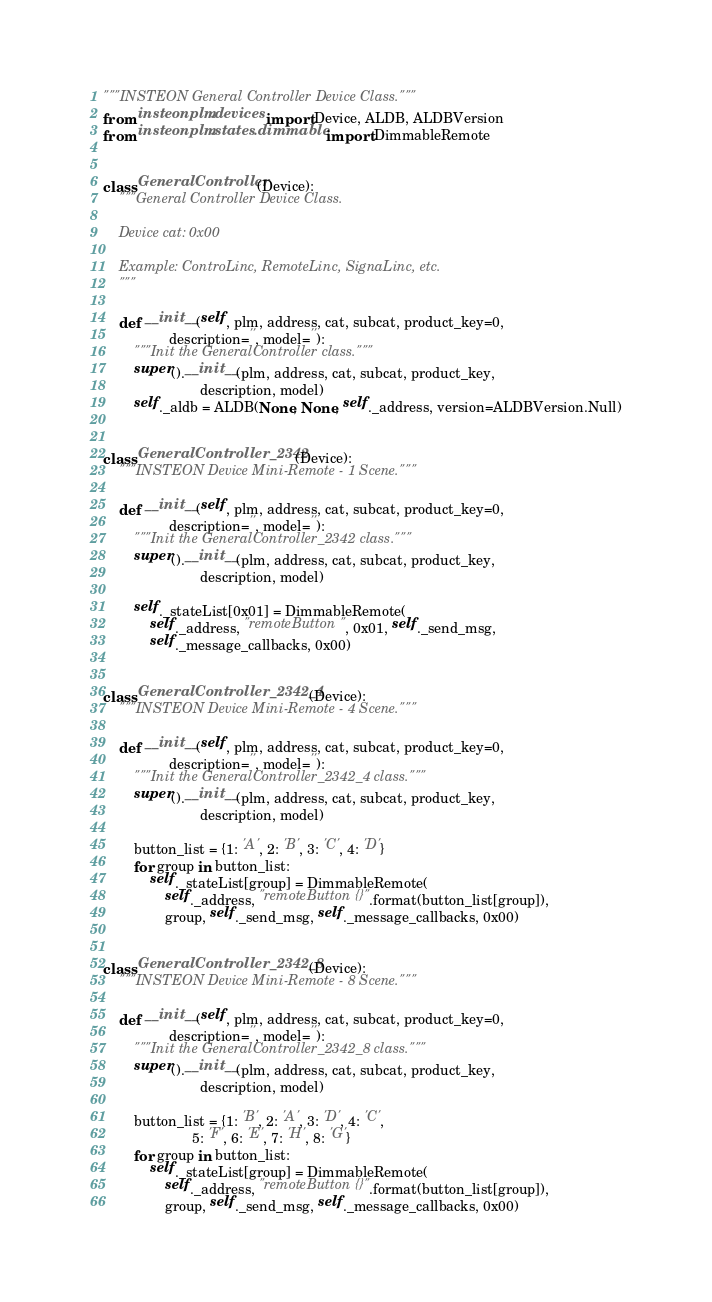Convert code to text. <code><loc_0><loc_0><loc_500><loc_500><_Python_>"""INSTEON General Controller Device Class."""
from insteonplm.devices import Device, ALDB, ALDBVersion
from insteonplm.states.dimmable import DimmableRemote


class GeneralController(Device):
    """General Controller Device Class.

    Device cat: 0x00

    Example: ControLinc, RemoteLinc, SignaLinc, etc.
    """

    def __init__(self, plm, address, cat, subcat, product_key=0,
                 description='', model=''):
        """Init the GeneralController class."""
        super().__init__(plm, address, cat, subcat, product_key,
                         description, model)
        self._aldb = ALDB(None, None, self._address, version=ALDBVersion.Null)


class GeneralController_2342(Device):
    """INSTEON Device Mini-Remote - 1 Scene."""

    def __init__(self, plm, address, cat, subcat, product_key=0,
                 description='', model=''):
        """Init the GeneralController_2342 class."""
        super().__init__(plm, address, cat, subcat, product_key,
                         description, model)

        self._stateList[0x01] = DimmableRemote(
            self._address, "remoteButton", 0x01, self._send_msg,
            self._message_callbacks, 0x00)


class GeneralController_2342_4(Device):
    """INSTEON Device Mini-Remote - 4 Scene."""

    def __init__(self, plm, address, cat, subcat, product_key=0,
                 description='', model=''):
        """Init the GeneralController_2342_4 class."""
        super().__init__(plm, address, cat, subcat, product_key,
                         description, model)

        button_list = {1: 'A', 2: 'B', 3: 'C', 4: 'D'}
        for group in button_list:
            self._stateList[group] = DimmableRemote(
                self._address, "remoteButton{}".format(button_list[group]),
                group, self._send_msg, self._message_callbacks, 0x00)


class GeneralController_2342_8(Device):
    """INSTEON Device Mini-Remote - 8 Scene."""

    def __init__(self, plm, address, cat, subcat, product_key=0,
                 description='', model=''):
        """Init the GeneralController_2342_8 class."""
        super().__init__(plm, address, cat, subcat, product_key,
                         description, model)

        button_list = {1: 'B', 2: 'A', 3: 'D', 4: 'C',
                       5: 'F', 6: 'E', 7: 'H', 8: 'G'}
        for group in button_list:
            self._stateList[group] = DimmableRemote(
                self._address, "remoteButton{}".format(button_list[group]),
                group, self._send_msg, self._message_callbacks, 0x00)
</code> 